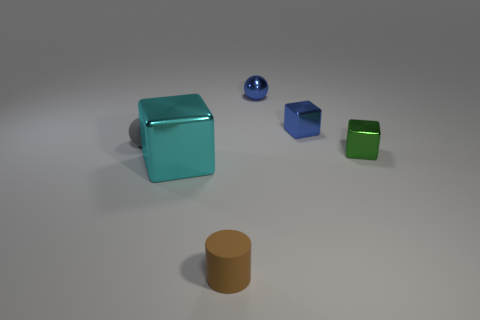Add 4 big purple rubber blocks. How many objects exist? 10 Subtract all balls. How many objects are left? 4 Add 6 gray matte spheres. How many gray matte spheres exist? 7 Subtract 0 cyan spheres. How many objects are left? 6 Subtract all gray balls. Subtract all tiny blue metallic balls. How many objects are left? 4 Add 6 small metal blocks. How many small metal blocks are left? 8 